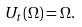<formula> <loc_0><loc_0><loc_500><loc_500>U _ { t } ( \Omega ) = \Omega .</formula> 